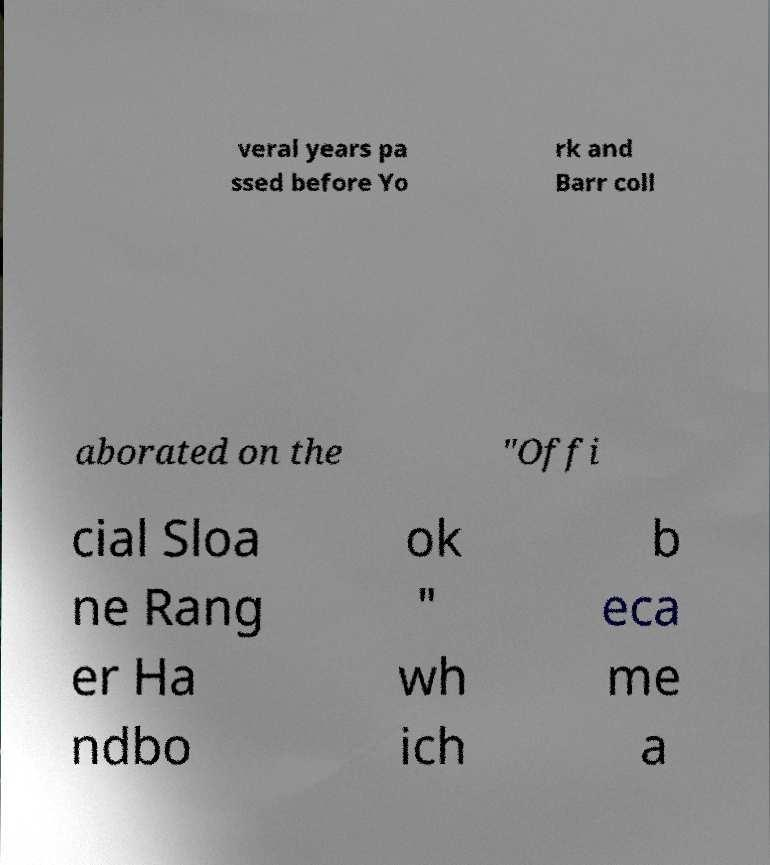Please identify and transcribe the text found in this image. veral years pa ssed before Yo rk and Barr coll aborated on the "Offi cial Sloa ne Rang er Ha ndbo ok " wh ich b eca me a 